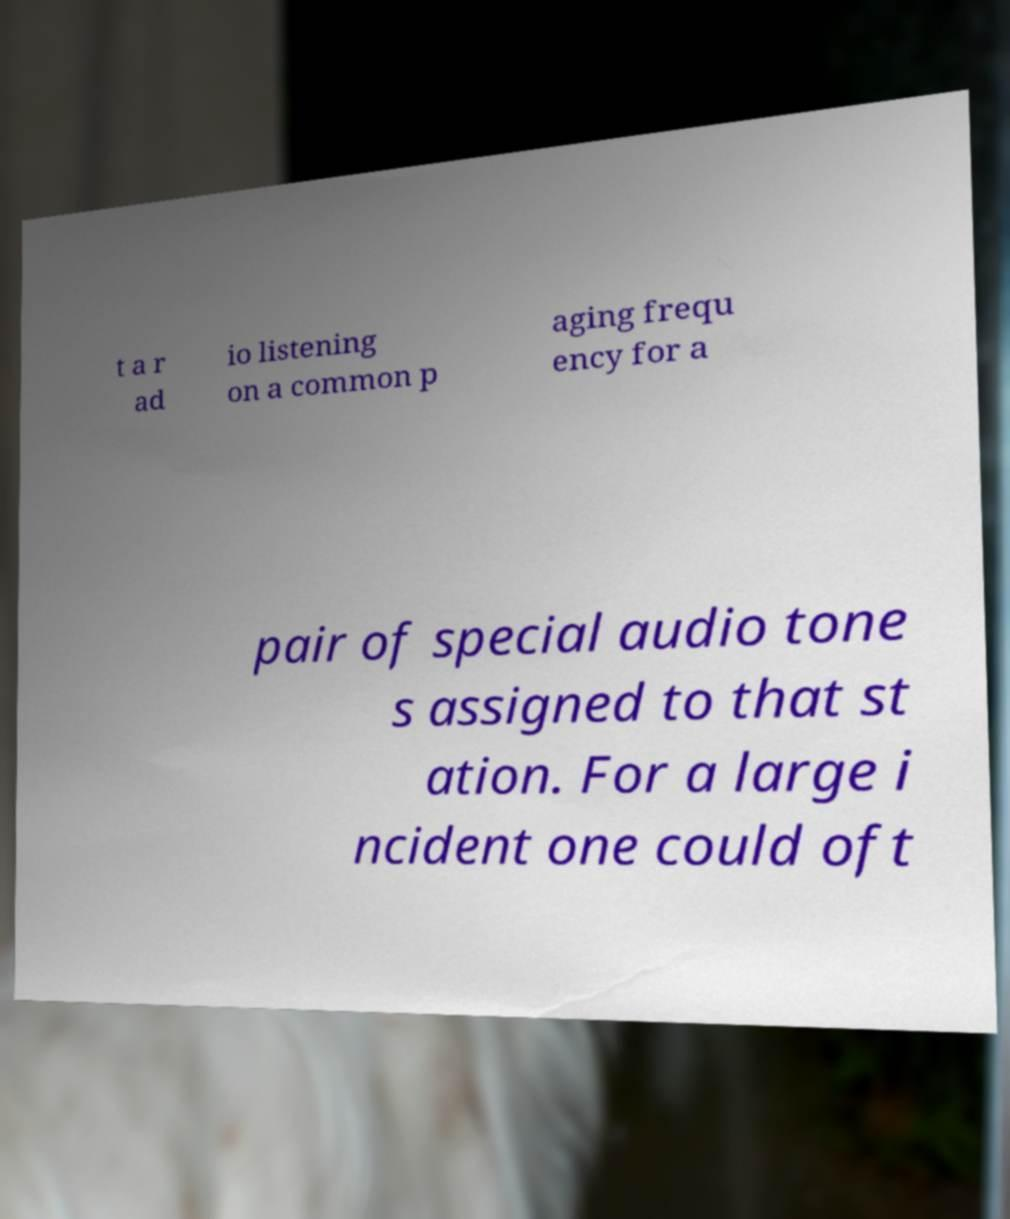Can you accurately transcribe the text from the provided image for me? t a r ad io listening on a common p aging frequ ency for a pair of special audio tone s assigned to that st ation. For a large i ncident one could oft 